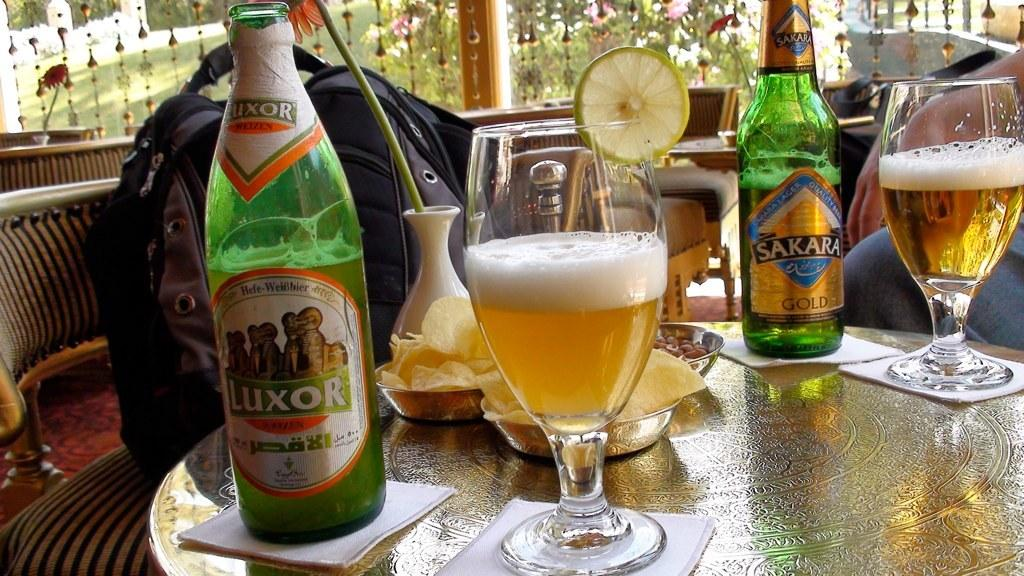<image>
Summarize the visual content of the image. Luxor and Sakara ales are poured into glasses at a restaurant table. 